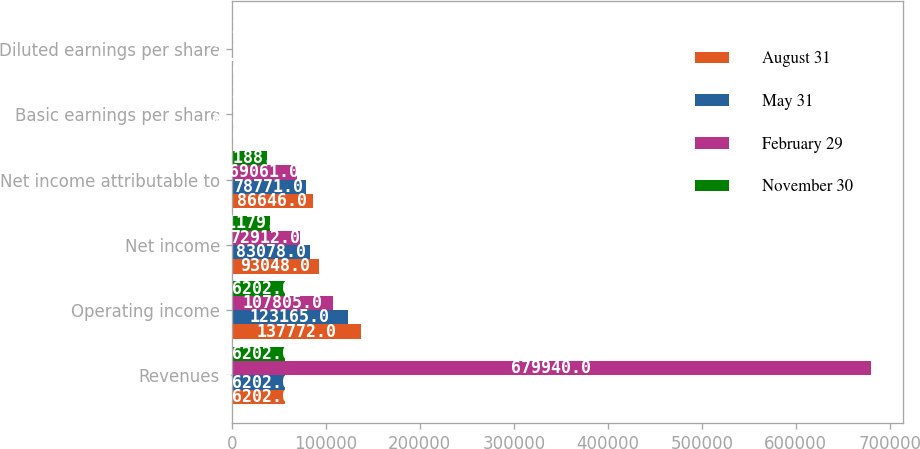Convert chart to OTSL. <chart><loc_0><loc_0><loc_500><loc_500><stacked_bar_chart><ecel><fcel>Revenues<fcel>Operating income<fcel>Net income<fcel>Net income attributable to<fcel>Basic earnings per share<fcel>Diluted earnings per share<nl><fcel>August 31<fcel>56202<fcel>137772<fcel>93048<fcel>86646<fcel>0.66<fcel>0.66<nl><fcel>May 31<fcel>56202<fcel>123165<fcel>83078<fcel>78771<fcel>0.61<fcel>0.6<nl><fcel>February 29<fcel>679940<fcel>107805<fcel>72912<fcel>69061<fcel>0.53<fcel>0.53<nl><fcel>November 30<fcel>56202<fcel>56202<fcel>41179<fcel>37188<fcel>0.27<fcel>0.26<nl></chart> 